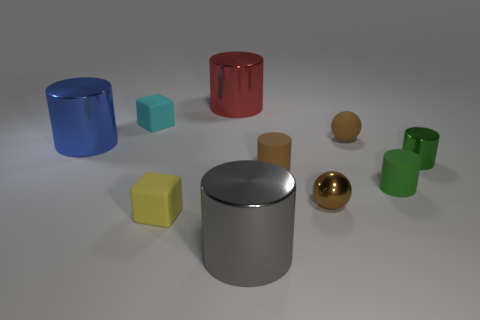There is a small cylinder that is made of the same material as the blue thing; what is its color?
Ensure brevity in your answer.  Green. Do the matte sphere and the tiny metal thing left of the small green shiny thing have the same color?
Provide a short and direct response. Yes. There is a object that is both on the right side of the rubber sphere and in front of the green shiny cylinder; what is its color?
Offer a terse response. Green. How many small blocks are behind the blue shiny cylinder?
Provide a succinct answer. 1. What number of things are purple cylinders or cylinders that are to the right of the big gray metal object?
Make the answer very short. 3. Are there any large metallic things that are on the right side of the big metallic cylinder in front of the big blue cylinder?
Offer a very short reply. No. There is a big cylinder in front of the blue shiny object; what is its color?
Give a very brief answer. Gray. Is the number of brown objects behind the big blue thing the same as the number of red cylinders?
Give a very brief answer. Yes. What shape is the thing that is both to the right of the yellow rubber thing and in front of the small brown metal object?
Your answer should be very brief. Cylinder. There is another tiny metallic thing that is the same shape as the red thing; what is its color?
Provide a succinct answer. Green. 